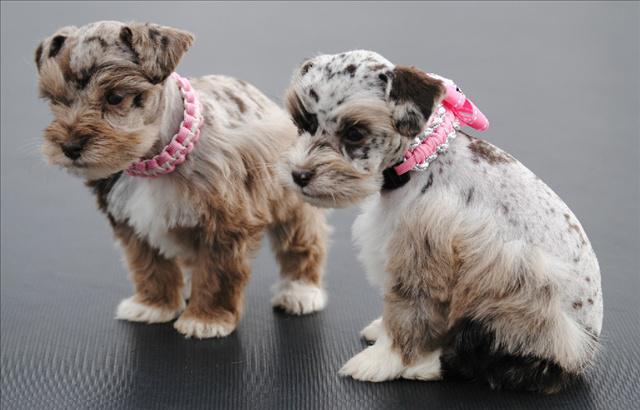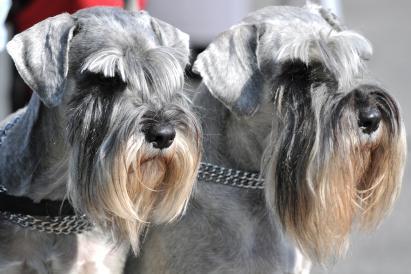The first image is the image on the left, the second image is the image on the right. Evaluate the accuracy of this statement regarding the images: "An image shows a schnauzer with bright green foliage.". Is it true? Answer yes or no. No. 